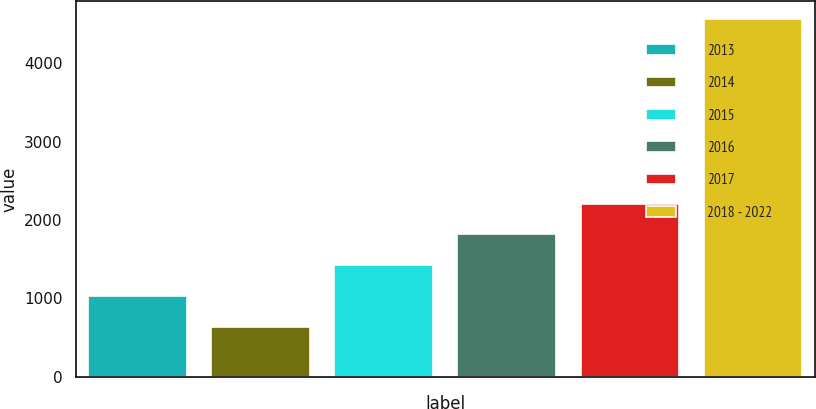<chart> <loc_0><loc_0><loc_500><loc_500><bar_chart><fcel>2013<fcel>2014<fcel>2015<fcel>2016<fcel>2017<fcel>2018 - 2022<nl><fcel>1029<fcel>636<fcel>1422<fcel>1815<fcel>2208<fcel>4566<nl></chart> 